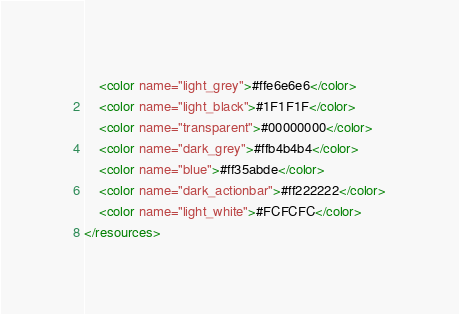<code> <loc_0><loc_0><loc_500><loc_500><_XML_>    <color name="light_grey">#ffe6e6e6</color>
    <color name="light_black">#1F1F1F</color>
    <color name="transparent">#00000000</color>
    <color name="dark_grey">#ffb4b4b4</color>
    <color name="blue">#ff35abde</color>
    <color name="dark_actionbar">#ff222222</color>
    <color name="light_white">#FCFCFC</color>
</resources>
</code> 